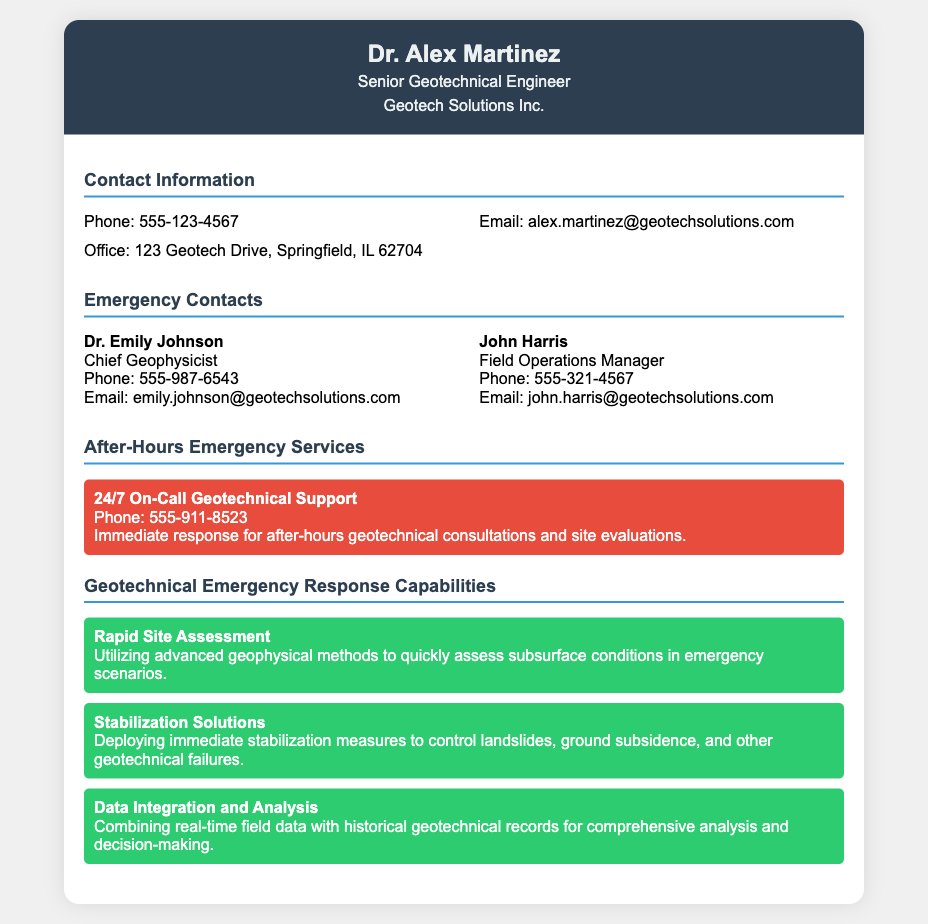What is the name of the senior geotechnical engineer? The senior geotechnical engineer's name is listed in the header section of the document.
Answer: Dr. Alex Martinez What is the email address of the chief geophysicist? The email of the chief geophysicist, Dr. Emily Johnson, is provided in the emergency contacts section.
Answer: emily.johnson@geotechsolutions.com What is the phone number for after-hours emergency services? The phone number for 24/7 on-call geotechnical support is stated in the after-hours emergency services section.
Answer: 555-911-8523 Which company does Dr. Alex Martinez work for? The company affiliation of Dr. Alex Martinez is mentioned in the header of the card.
Answer: Geotech Solutions Inc How many geotechnical emergency response capabilities are listed? The document provides three specific capabilities under the section for geotechnical emergency response capabilities.
Answer: Three What type of support is provided by the after-hours emergency service? The nature of the after-hours emergency service, which is for consultations and site evaluations, is specified in the document.
Answer: Immediate response for after-hours geotechnical consultations and site evaluations Who is the Field Operations Manager? The name and title of the Field Operations Manager is found in the emergency contacts section.
Answer: John Harris What type of assessment is described under the rapid site assessment capability? The assessment capability detailed is related to assessing subsurface conditions using certain methods.
Answer: Advanced geophysical methods What does the stabilization solutions capability involve? The capability emphasizes the action taken to control certain geotechnical problems.
Answer: Immediate stabilization measures 